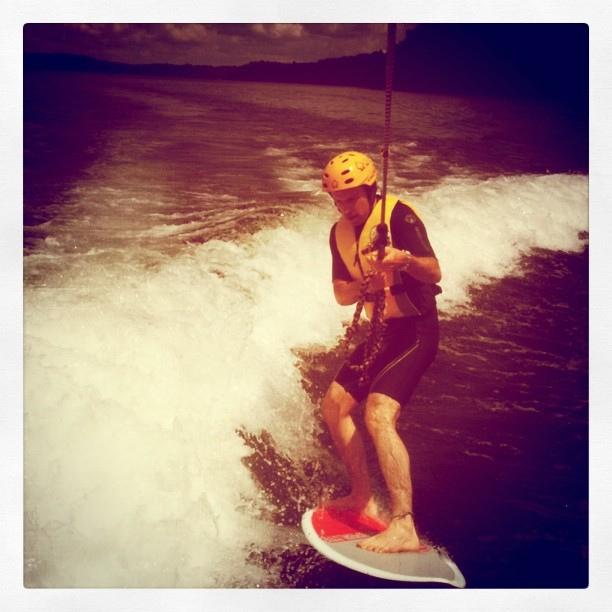What color is the man's helmet?
Short answer required. Yellow. What is the man doing?
Short answer required. Surfing. Is he being towed?
Short answer required. Yes. 